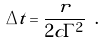Convert formula to latex. <formula><loc_0><loc_0><loc_500><loc_500>\Delta t = \frac { r } { 2 c \Gamma ^ { 2 } } \ .</formula> 